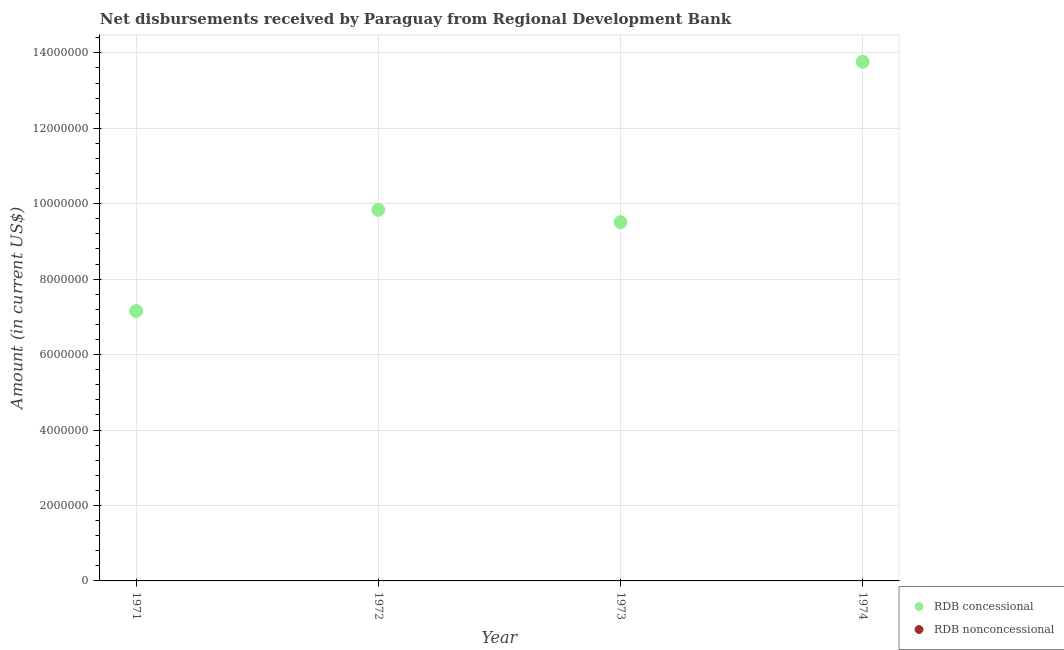Is the number of dotlines equal to the number of legend labels?
Ensure brevity in your answer.  No. What is the net concessional disbursements from rdb in 1972?
Your answer should be very brief. 9.84e+06. Across all years, what is the maximum net concessional disbursements from rdb?
Your response must be concise. 1.38e+07. In which year was the net concessional disbursements from rdb maximum?
Provide a succinct answer. 1974. What is the total net non concessional disbursements from rdb in the graph?
Give a very brief answer. 0. What is the difference between the net concessional disbursements from rdb in 1971 and that in 1972?
Make the answer very short. -2.68e+06. What is the difference between the net concessional disbursements from rdb in 1972 and the net non concessional disbursements from rdb in 1973?
Give a very brief answer. 9.84e+06. What is the average net concessional disbursements from rdb per year?
Make the answer very short. 1.01e+07. What is the ratio of the net concessional disbursements from rdb in 1971 to that in 1973?
Provide a succinct answer. 0.75. What is the difference between the highest and the second highest net concessional disbursements from rdb?
Give a very brief answer. 3.92e+06. What is the difference between the highest and the lowest net concessional disbursements from rdb?
Your answer should be compact. 6.61e+06. Does the net non concessional disbursements from rdb monotonically increase over the years?
Offer a terse response. No. Is the net concessional disbursements from rdb strictly greater than the net non concessional disbursements from rdb over the years?
Keep it short and to the point. Yes. Is the net concessional disbursements from rdb strictly less than the net non concessional disbursements from rdb over the years?
Your response must be concise. No. How many dotlines are there?
Offer a very short reply. 1. How many years are there in the graph?
Keep it short and to the point. 4. Are the values on the major ticks of Y-axis written in scientific E-notation?
Your answer should be compact. No. Does the graph contain grids?
Offer a terse response. Yes. Where does the legend appear in the graph?
Your answer should be very brief. Bottom right. How many legend labels are there?
Ensure brevity in your answer.  2. How are the legend labels stacked?
Your response must be concise. Vertical. What is the title of the graph?
Ensure brevity in your answer.  Net disbursements received by Paraguay from Regional Development Bank. Does "Lowest 20% of population" appear as one of the legend labels in the graph?
Provide a short and direct response. No. What is the Amount (in current US$) in RDB concessional in 1971?
Offer a terse response. 7.16e+06. What is the Amount (in current US$) in RDB nonconcessional in 1971?
Provide a short and direct response. 0. What is the Amount (in current US$) in RDB concessional in 1972?
Ensure brevity in your answer.  9.84e+06. What is the Amount (in current US$) of RDB nonconcessional in 1972?
Ensure brevity in your answer.  0. What is the Amount (in current US$) of RDB concessional in 1973?
Make the answer very short. 9.51e+06. What is the Amount (in current US$) in RDB nonconcessional in 1973?
Give a very brief answer. 0. What is the Amount (in current US$) of RDB concessional in 1974?
Offer a very short reply. 1.38e+07. Across all years, what is the maximum Amount (in current US$) in RDB concessional?
Make the answer very short. 1.38e+07. Across all years, what is the minimum Amount (in current US$) in RDB concessional?
Ensure brevity in your answer.  7.16e+06. What is the total Amount (in current US$) in RDB concessional in the graph?
Make the answer very short. 4.03e+07. What is the total Amount (in current US$) in RDB nonconcessional in the graph?
Your response must be concise. 0. What is the difference between the Amount (in current US$) of RDB concessional in 1971 and that in 1972?
Make the answer very short. -2.68e+06. What is the difference between the Amount (in current US$) of RDB concessional in 1971 and that in 1973?
Make the answer very short. -2.36e+06. What is the difference between the Amount (in current US$) of RDB concessional in 1971 and that in 1974?
Make the answer very short. -6.61e+06. What is the difference between the Amount (in current US$) in RDB concessional in 1972 and that in 1973?
Your response must be concise. 3.28e+05. What is the difference between the Amount (in current US$) in RDB concessional in 1972 and that in 1974?
Give a very brief answer. -3.92e+06. What is the difference between the Amount (in current US$) of RDB concessional in 1973 and that in 1974?
Make the answer very short. -4.25e+06. What is the average Amount (in current US$) of RDB concessional per year?
Offer a very short reply. 1.01e+07. What is the ratio of the Amount (in current US$) of RDB concessional in 1971 to that in 1972?
Provide a succinct answer. 0.73. What is the ratio of the Amount (in current US$) in RDB concessional in 1971 to that in 1973?
Offer a very short reply. 0.75. What is the ratio of the Amount (in current US$) of RDB concessional in 1971 to that in 1974?
Your answer should be very brief. 0.52. What is the ratio of the Amount (in current US$) in RDB concessional in 1972 to that in 1973?
Ensure brevity in your answer.  1.03. What is the ratio of the Amount (in current US$) of RDB concessional in 1972 to that in 1974?
Your answer should be compact. 0.71. What is the ratio of the Amount (in current US$) of RDB concessional in 1973 to that in 1974?
Ensure brevity in your answer.  0.69. What is the difference between the highest and the second highest Amount (in current US$) in RDB concessional?
Offer a very short reply. 3.92e+06. What is the difference between the highest and the lowest Amount (in current US$) in RDB concessional?
Your response must be concise. 6.61e+06. 